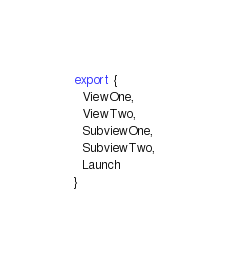Convert code to text. <code><loc_0><loc_0><loc_500><loc_500><_JavaScript_>export {
  ViewOne,
  ViewTwo,
  SubviewOne,
  SubviewTwo,
  Launch
}
</code> 